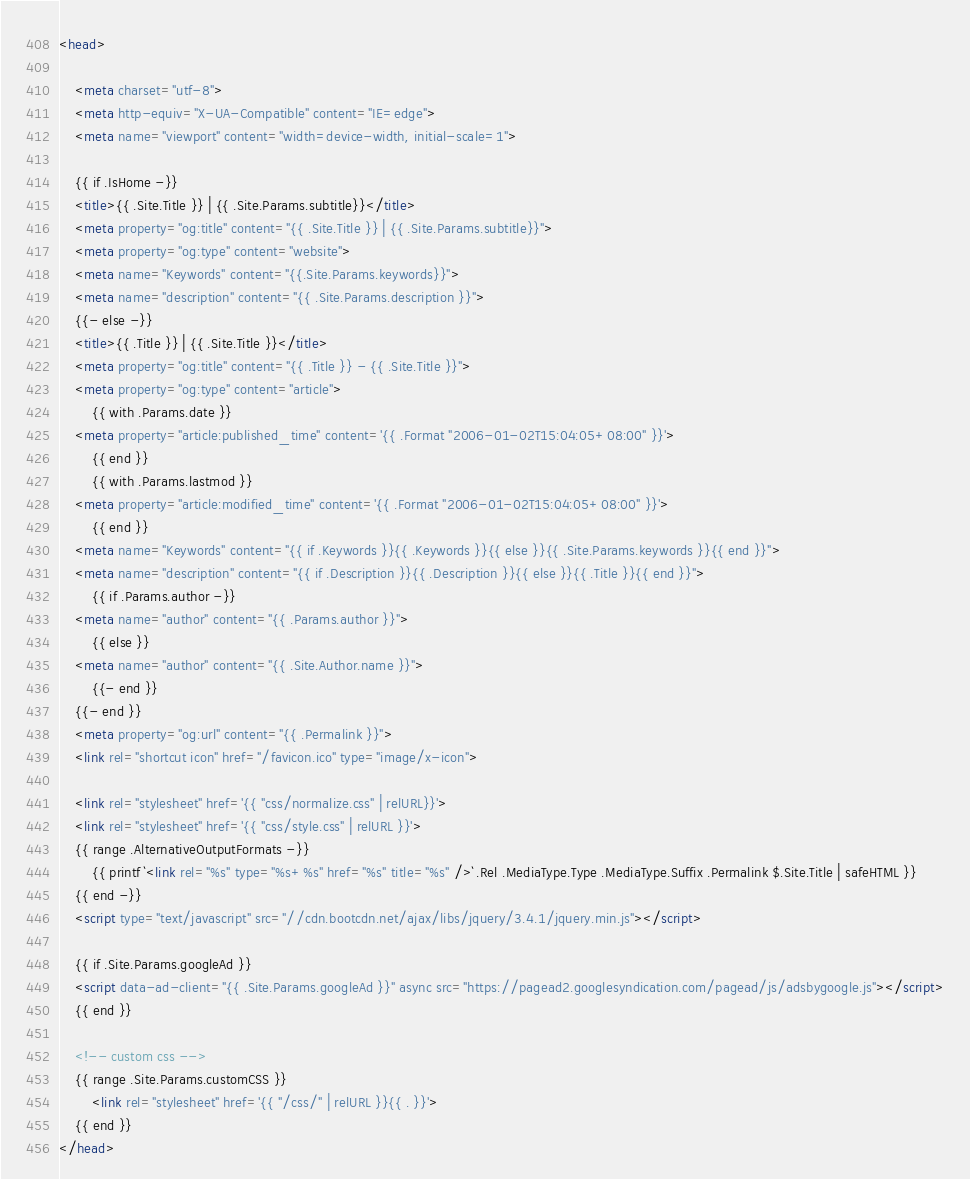Convert code to text. <code><loc_0><loc_0><loc_500><loc_500><_HTML_><head>

    <meta charset="utf-8">
    <meta http-equiv="X-UA-Compatible" content="IE=edge">
    <meta name="viewport" content="width=device-width, initial-scale=1">

    {{ if .IsHome -}}
    <title>{{ .Site.Title }} | {{ .Site.Params.subtitle}}</title>
    <meta property="og:title" content="{{ .Site.Title }} | {{ .Site.Params.subtitle}}">
    <meta property="og:type" content="website">
    <meta name="Keywords" content="{{.Site.Params.keywords}}">
    <meta name="description" content="{{ .Site.Params.description }}">
    {{- else -}}
    <title>{{ .Title }} | {{ .Site.Title }}</title>
    <meta property="og:title" content="{{ .Title }} - {{ .Site.Title }}">
    <meta property="og:type" content="article">
        {{ with .Params.date }}
    <meta property="article:published_time" content='{{ .Format "2006-01-02T15:04:05+08:00" }}'>
        {{ end }}
        {{ with .Params.lastmod }}
    <meta property="article:modified_time" content='{{ .Format "2006-01-02T15:04:05+08:00" }}'>
        {{ end }}
    <meta name="Keywords" content="{{ if .Keywords }}{{ .Keywords }}{{ else }}{{ .Site.Params.keywords }}{{ end }}">
    <meta name="description" content="{{ if .Description }}{{ .Description }}{{ else }}{{ .Title }}{{ end }}">
        {{ if .Params.author -}}
    <meta name="author" content="{{ .Params.author }}">
        {{ else }}
    <meta name="author" content="{{ .Site.Author.name }}">
        {{- end }}
    {{- end }}
    <meta property="og:url" content="{{ .Permalink }}">
    <link rel="shortcut icon" href="/favicon.ico" type="image/x-icon">

    <link rel="stylesheet" href='{{ "css/normalize.css" | relURL}}'>
    <link rel="stylesheet" href='{{ "css/style.css" | relURL }}'>
    {{ range .AlternativeOutputFormats -}}
        {{ printf `<link rel="%s" type="%s+%s" href="%s" title="%s" />` .Rel .MediaType.Type .MediaType.Suffix .Permalink $.Site.Title | safeHTML }}
    {{ end -}}
    <script type="text/javascript" src="//cdn.bootcdn.net/ajax/libs/jquery/3.4.1/jquery.min.js"></script>

    {{ if .Site.Params.googleAd }}
    <script data-ad-client="{{ .Site.Params.googleAd }}" async src="https://pagead2.googlesyndication.com/pagead/js/adsbygoogle.js"></script>
    {{ end }}
    
    <!-- custom css -->
    {{ range .Site.Params.customCSS }}
        <link rel="stylesheet" href='{{ "/css/" | relURL }}{{ . }}'>
    {{ end }}
</head>
</code> 